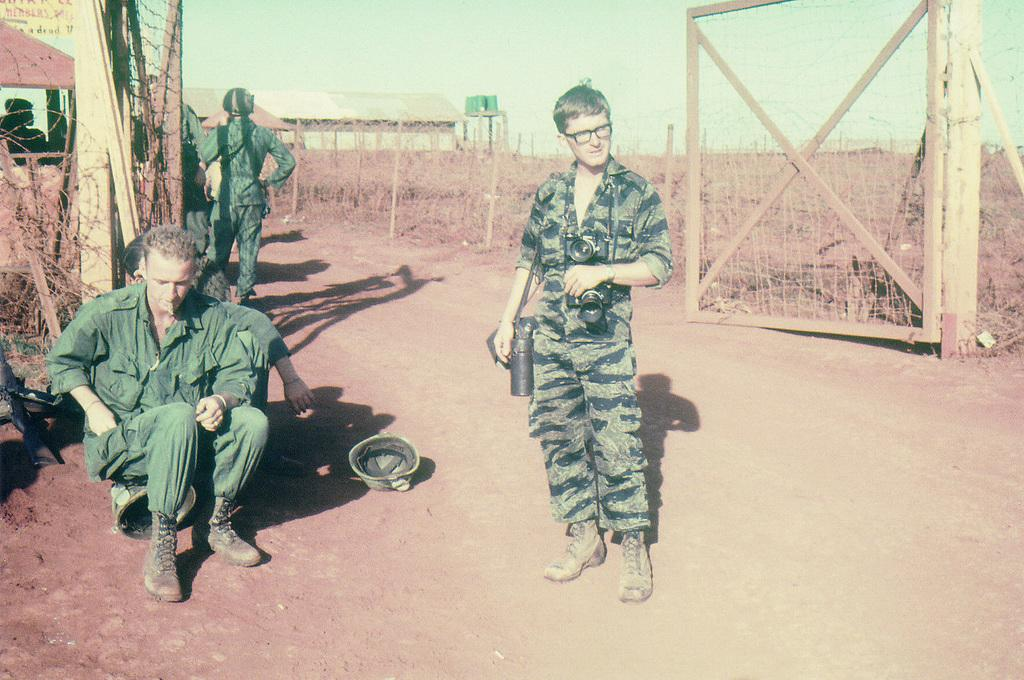How many people can be seen in the image? There are people in the image, but the exact number is not specified. What is one person wearing in the image? One person is wearing a camera in the image. What type of structures are present in the image? There are sheds in the image. What are the poles used for in the image? The purpose of the poles is not specified in the image. What type of vegetation is visible in the image? Grass is visible in the image. What type of barrier is present in the image? There is a fence in the image. What type of entrance is present in the image? A gate is present in the image. What is visible in the background of the image? The sky is visible in the background of the image. How many rabbits can be seen hopping through the grass in the image? There are no rabbits present in the image. What type of fiction is being read by the people in the image? There is no indication of any reading material or fiction in the image. 